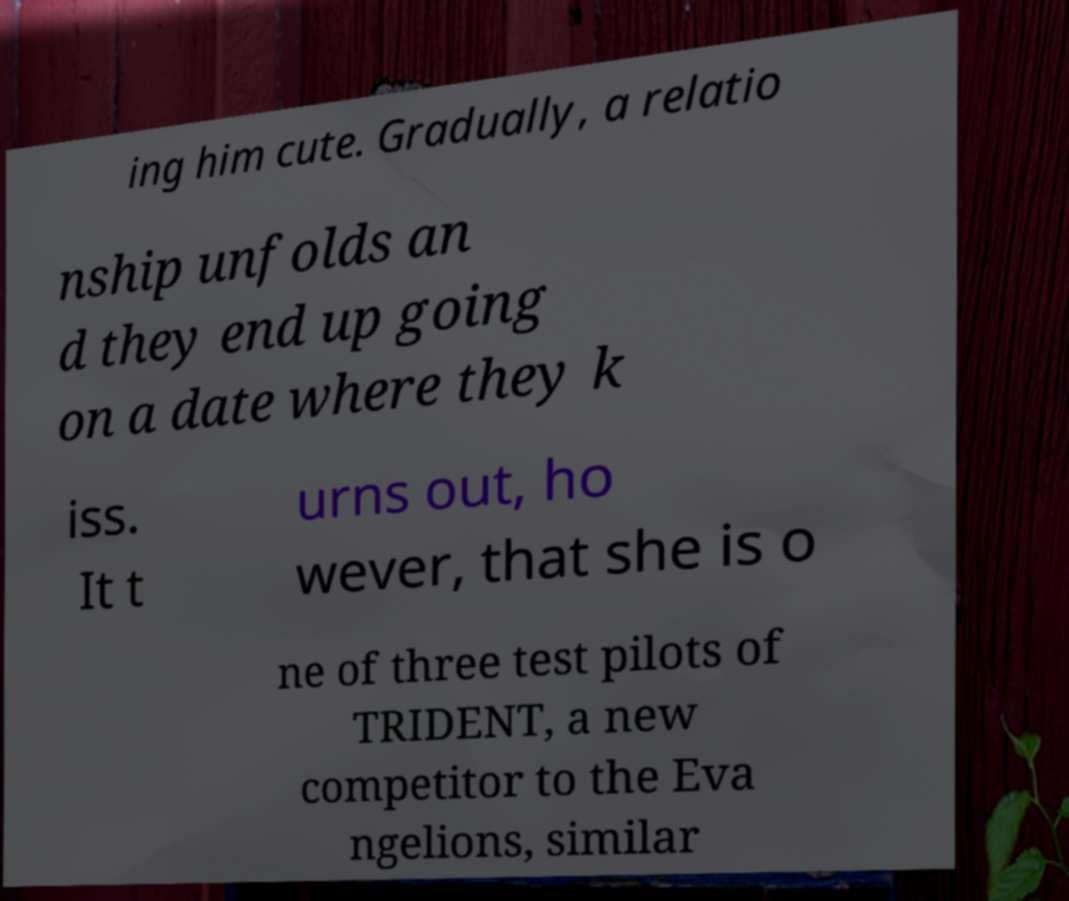For documentation purposes, I need the text within this image transcribed. Could you provide that? ing him cute. Gradually, a relatio nship unfolds an d they end up going on a date where they k iss. It t urns out, ho wever, that she is o ne of three test pilots of TRIDENT, a new competitor to the Eva ngelions, similar 